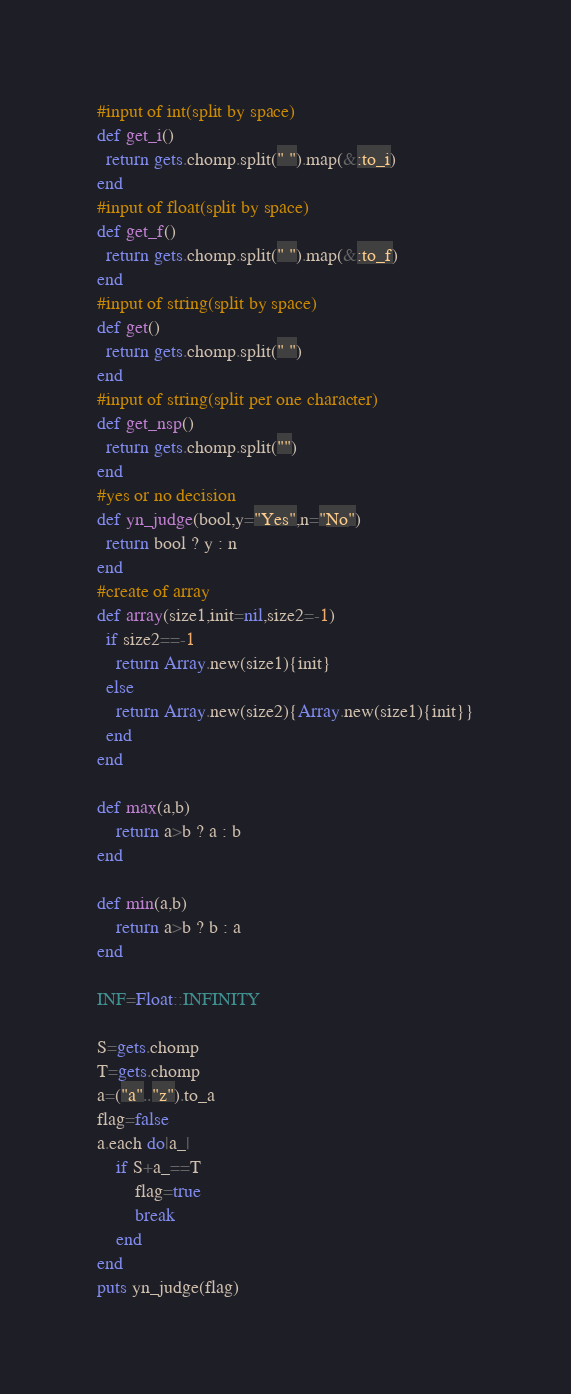Convert code to text. <code><loc_0><loc_0><loc_500><loc_500><_Ruby_>#input of int(split by space)
def get_i()
  return gets.chomp.split(" ").map(&:to_i)
end
#input of float(split by space)
def get_f()
  return gets.chomp.split(" ").map(&:to_f)
end
#input of string(split by space)
def get()
  return gets.chomp.split(" ")
end
#input of string(split per one character)
def get_nsp()
  return gets.chomp.split("")
end
#yes or no decision
def yn_judge(bool,y="Yes",n="No")
  return bool ? y : n 
end
#create of array
def array(size1,init=nil,size2=-1)
  if size2==-1
    return Array.new(size1){init}
  else
    return Array.new(size2){Array.new(size1){init}}
  end
end

def max(a,b)
    return a>b ? a : b
end

def min(a,b)
    return a>b ? b : a
end

INF=Float::INFINITY

S=gets.chomp
T=gets.chomp
a=("a".."z").to_a
flag=false
a.each do|a_|
    if S+a_==T
        flag=true
        break
    end
end
puts yn_judge(flag)</code> 